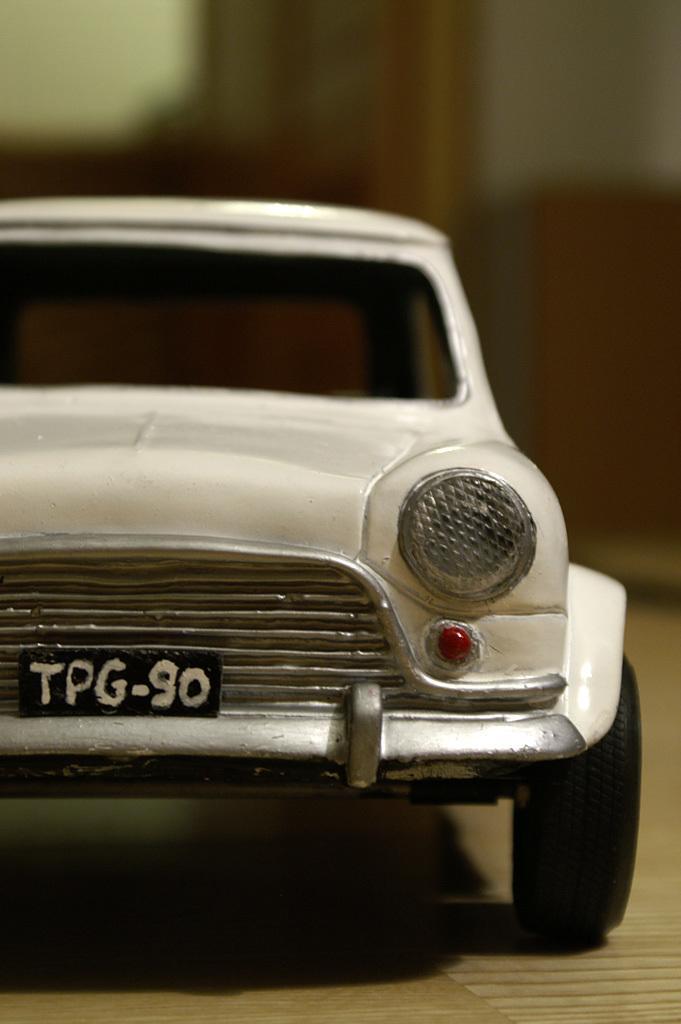Can you describe this image briefly? In this picture I can see a toy car in the middle, it is in white color. 